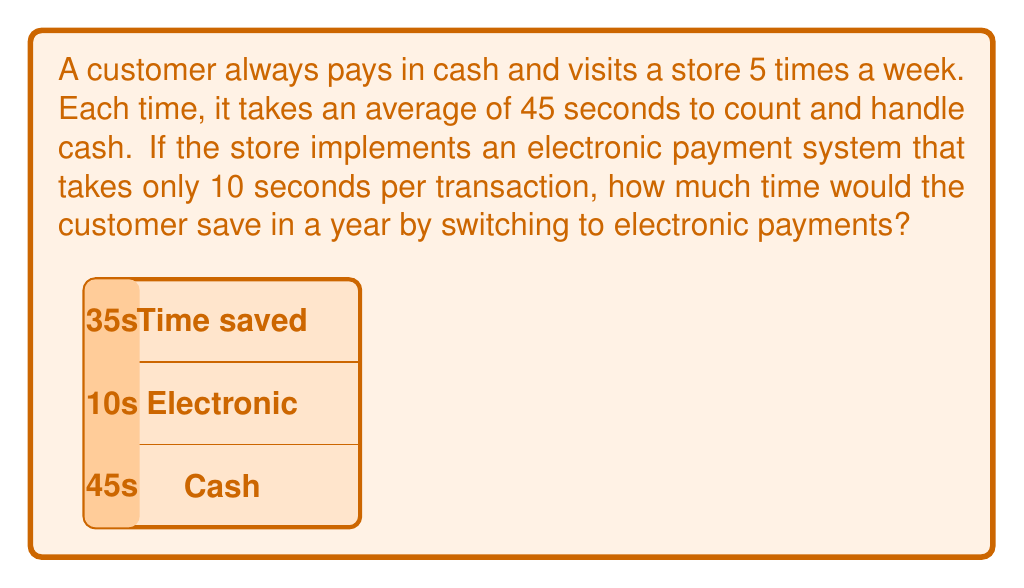Solve this math problem. Let's break this down step-by-step:

1) First, calculate the time spent on cash transactions per week:
   $$ 45 \text{ seconds} \times 5 \text{ visits} = 225 \text{ seconds per week} $$

2) Now, calculate the time that would be spent on electronic transactions per week:
   $$ 10 \text{ seconds} \times 5 \text{ visits} = 50 \text{ seconds per week} $$

3) The time saved per week is the difference between these two:
   $$ 225 \text{ seconds} - 50 \text{ seconds} = 175 \text{ seconds per week} $$

4) To find the time saved in a year, multiply by the number of weeks in a year:
   $$ 175 \text{ seconds} \times 52 \text{ weeks} = 9,100 \text{ seconds} $$

5) Convert seconds to minutes:
   $$ 9,100 \text{ seconds} \div 60 = 151.67 \text{ minutes} $$

6) Round to the nearest minute:
   $$ 151.67 \text{ minutes} \approx 152 \text{ minutes} $$

Therefore, the customer would save approximately 152 minutes, or 2 hours and 32 minutes, in a year by switching to electronic payments.
Answer: 152 minutes 